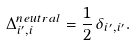<formula> <loc_0><loc_0><loc_500><loc_500>\Delta _ { i ^ { \prime } , i } ^ { n e u t r a l } = \frac { 1 } { 2 } \, \delta _ { i ^ { \prime } , i ^ { \prime } } .</formula> 